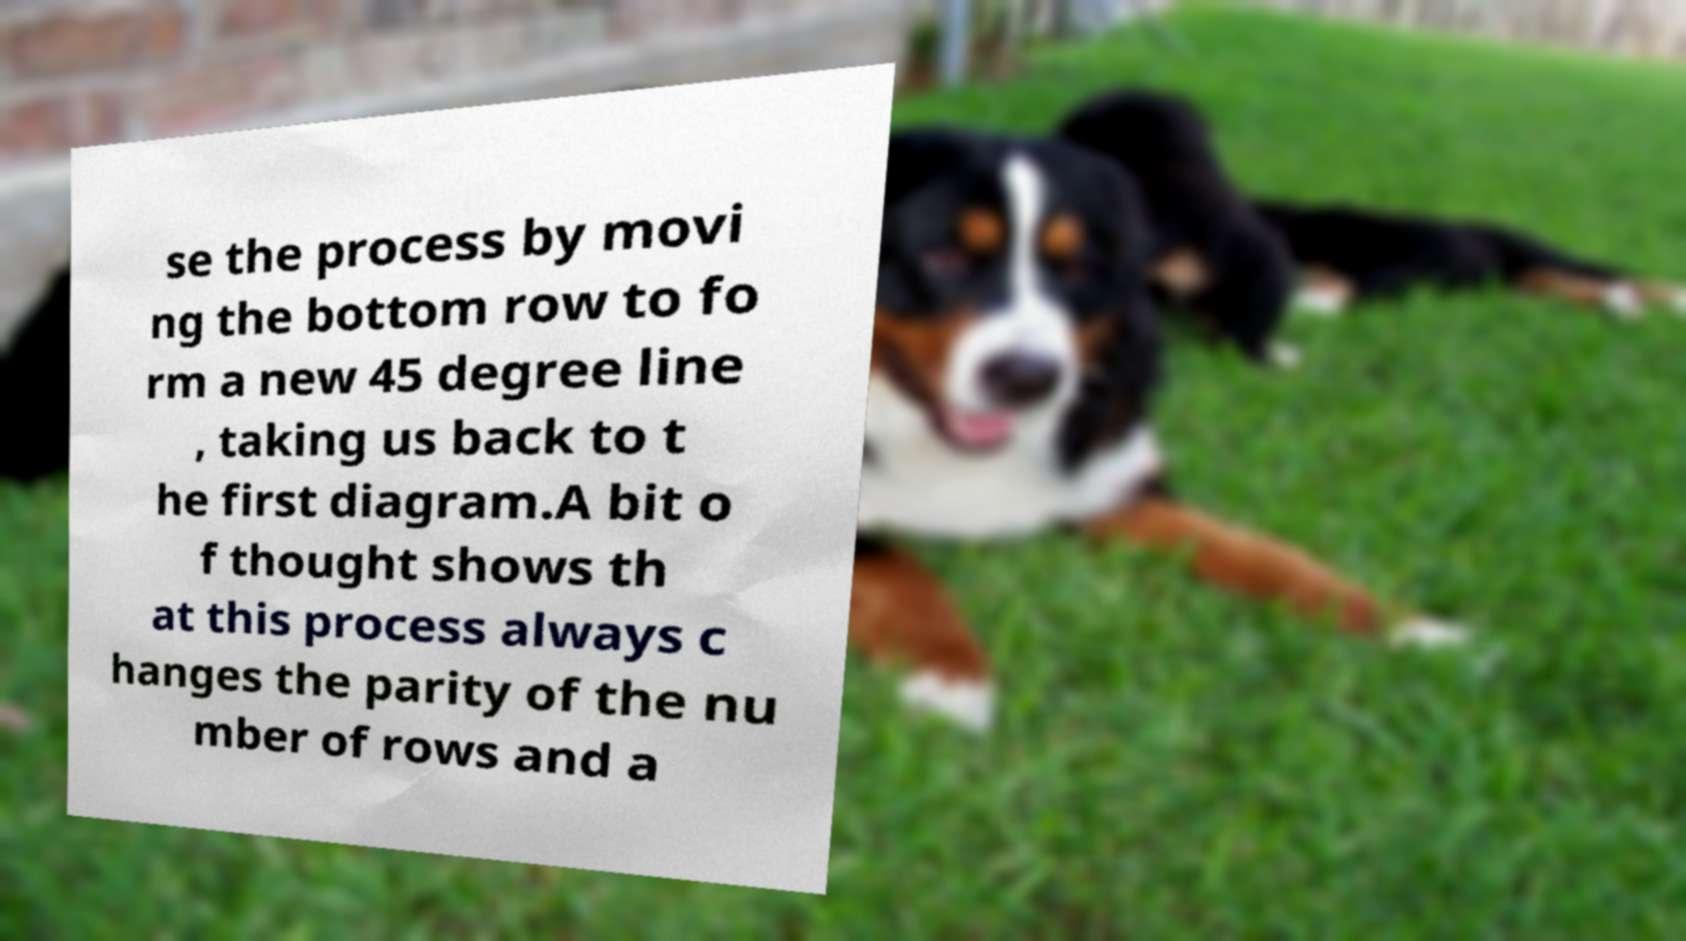What messages or text are displayed in this image? I need them in a readable, typed format. se the process by movi ng the bottom row to fo rm a new 45 degree line , taking us back to t he first diagram.A bit o f thought shows th at this process always c hanges the parity of the nu mber of rows and a 